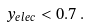<formula> <loc_0><loc_0><loc_500><loc_500>y _ { e l e c } < 0 . 7 \, .</formula> 